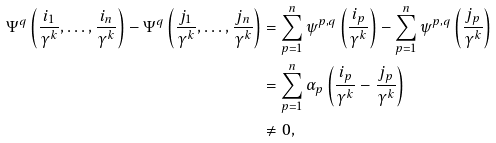<formula> <loc_0><loc_0><loc_500><loc_500>\Psi ^ { q } \left ( \frac { i _ { 1 } } { \gamma ^ { k } } , \dots , \frac { i _ { n } } { \gamma ^ { k } } \right ) - \Psi ^ { q } \left ( \frac { j _ { 1 } } { \gamma ^ { k } } , \dots , \frac { j _ { n } } { \gamma ^ { k } } \right ) & = \sum _ { p = 1 } ^ { n } \psi ^ { p , q } \left ( \frac { i _ { p } } { \gamma ^ { k } } \right ) - \sum _ { p = 1 } ^ { n } \psi ^ { p , q } \left ( \frac { j _ { p } } { \gamma ^ { k } } \right ) \\ & = \sum _ { p = 1 } ^ { n } \alpha _ { p } \left ( \frac { i _ { p } } { \gamma ^ { k } } - \frac { j _ { p } } { \gamma ^ { k } } \right ) \\ & \ne 0 ,</formula> 